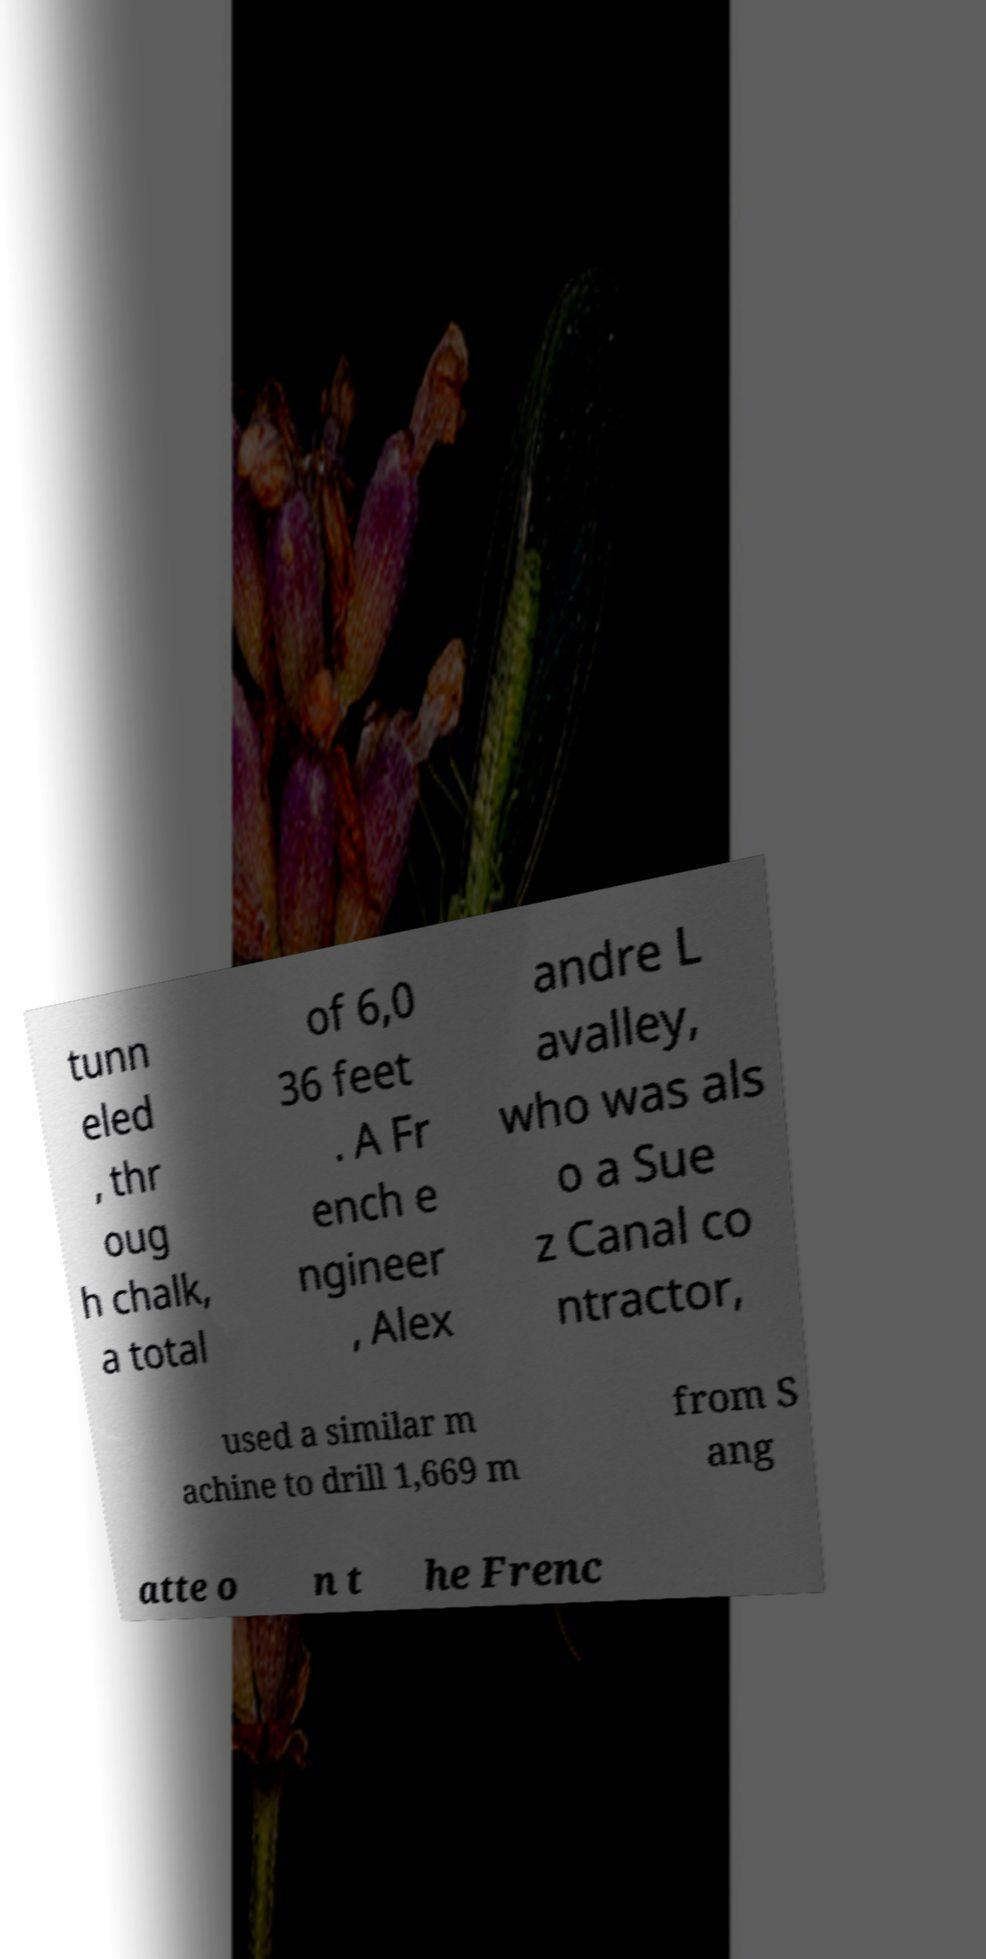What messages or text are displayed in this image? I need them in a readable, typed format. tunn eled , thr oug h chalk, a total of 6,0 36 feet . A Fr ench e ngineer , Alex andre L avalley, who was als o a Sue z Canal co ntractor, used a similar m achine to drill 1,669 m from S ang atte o n t he Frenc 